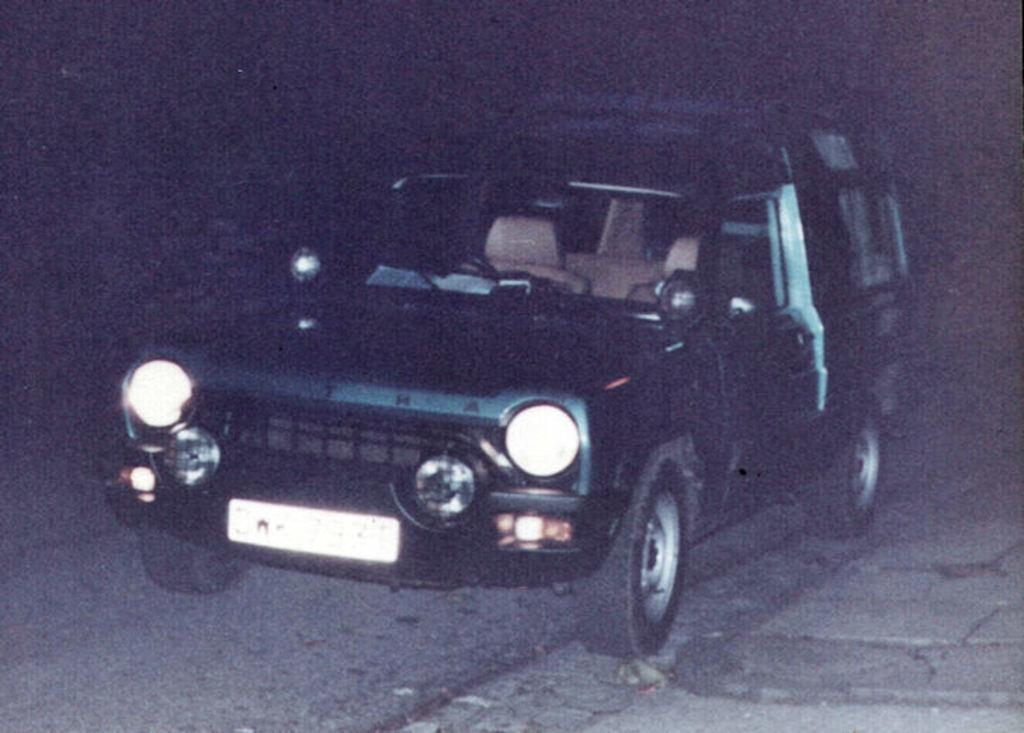What is the main subject in the foreground of the image? There is a vehicle on the road in the foreground of the image. What type of surface is visible on the right bottom of the image? There is a pavement on the right bottom of the image. How would you describe the background of the image? The background of the image is dark. Can you see any impulses or stockings in the image? There are no impulses or stockings present in the image. Are there any cacti visible in the image? There is no cactus present in the image. 